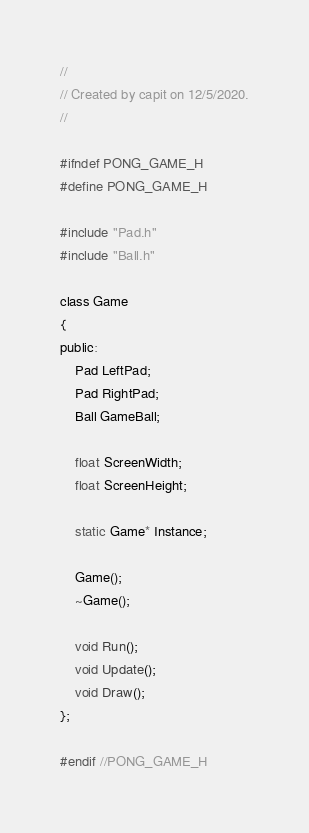Convert code to text. <code><loc_0><loc_0><loc_500><loc_500><_C_>//
// Created by capit on 12/5/2020.
//

#ifndef PONG_GAME_H
#define PONG_GAME_H

#include "Pad.h"
#include "Ball.h"

class Game
{
public:
    Pad LeftPad;
    Pad RightPad;
    Ball GameBall;
    
    float ScreenWidth;
    float ScreenHeight;
    
    static Game* Instance;
    
    Game();
    ~Game();
    
    void Run();
    void Update();
    void Draw();
};

#endif //PONG_GAME_H
</code> 